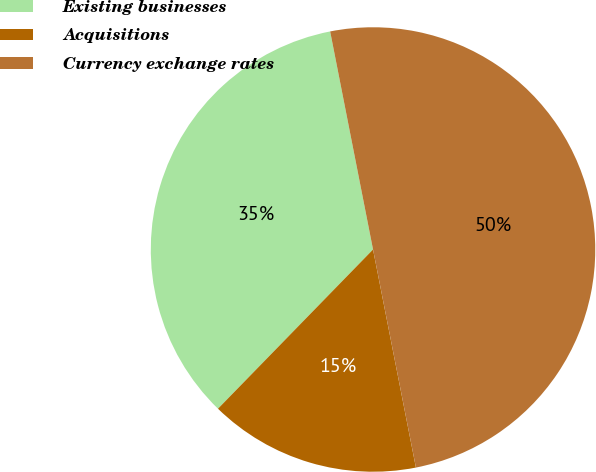Convert chart to OTSL. <chart><loc_0><loc_0><loc_500><loc_500><pie_chart><fcel>Existing businesses<fcel>Acquisitions<fcel>Currency exchange rates<nl><fcel>34.62%<fcel>15.38%<fcel>50.0%<nl></chart> 